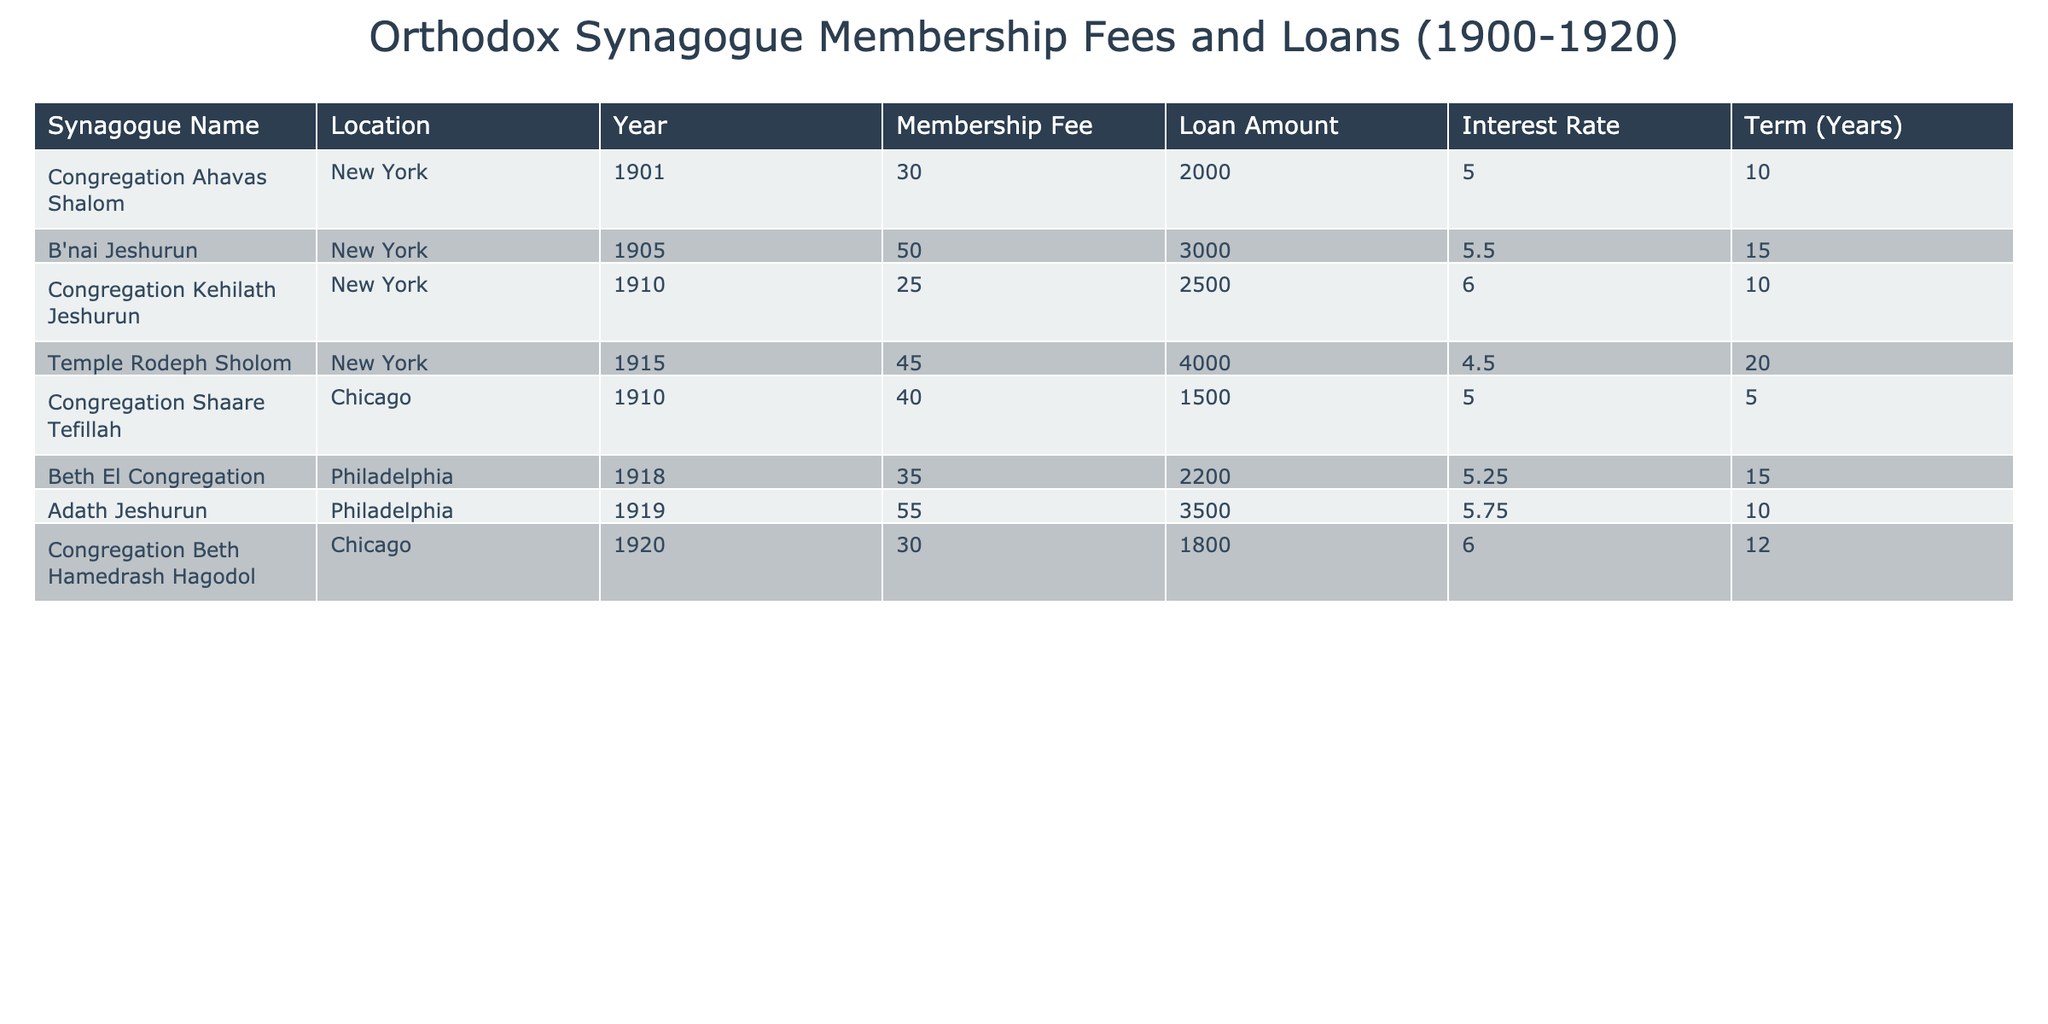What is the highest membership fee among the synagogues listed? By looking through the "Membership Fee" column, it is clear that Adath Jeshurun has the highest membership fee of 55 dollars.
Answer: 55 Which synagogue located in New York has a membership fee of 30 dollars? Scanning the table, Congregation Ahavas Shalom is identified in the first row as the New York synagogue with a membership fee of 30 dollars.
Answer: Congregation Ahavas Shalom What is the loan amount for B'nai Jeshurun? The loan amount for B'nai Jeshurun, as noted in the table, is 3000 dollars.
Answer: 3000 How many synagogues have a membership fee greater than 30 dollars? Analyzing the "Membership Fee" column, the synagogues with fees greater than 30 dollars are B'nai Jeshurun (50), Adath Jeshurun (55), Temple Rodeph Sholom (45), and Congregation Shaare Tefillah (40). This totals 4 synagogues.
Answer: 4 What is the average loan amount for synagogues in Chicago? The loan amounts for Chicago synagogues are 1500 (Congregation Shaare Tefillah) and 1800 (Congregation Beth Hamedrash Hagodol). Summing these provides 3300 dollars, and dividing by 2 gives an average of 1650 dollars.
Answer: 1650 Do any of the synagogues have a loan amount of less than 2000 dollars? Reviewing the "Loan Amount" column, Congregation Shaare Tefillah has a loan amount of 1500 dollars, which confirms that there is at least one synagogue with a loan below 2000 dollars.
Answer: Yes Is the interest rate for Temple Rodeph Sholom lower than 5 percent? The interest rate for Temple Rodeph Sholom is noted as 4.5 percent, which is indeed lower than 5 percent.
Answer: Yes What is the difference in membership fees between the highest and lowest fees? The highest fee is 55 dollars (Adath Jeshurun) and the lowest is 25 dollars (Congregation Kehilath Jeshurun). The difference is calculated by subtracting the lowest from the highest: 55 - 25 = 30 dollars.
Answer: 30 